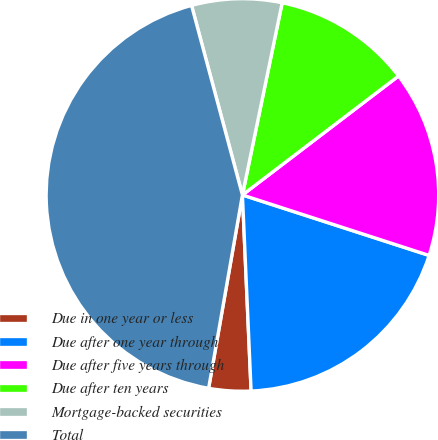Convert chart to OTSL. <chart><loc_0><loc_0><loc_500><loc_500><pie_chart><fcel>Due in one year or less<fcel>Due after one year through<fcel>Due after five years through<fcel>Due after ten years<fcel>Mortgage-backed securities<fcel>Total<nl><fcel>3.46%<fcel>19.31%<fcel>15.35%<fcel>11.39%<fcel>7.42%<fcel>43.07%<nl></chart> 